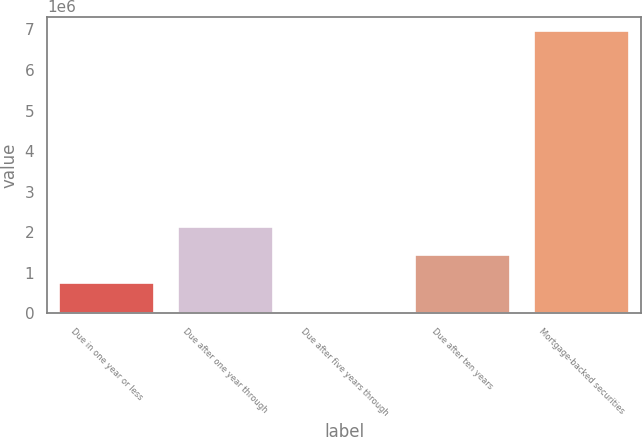Convert chart to OTSL. <chart><loc_0><loc_0><loc_500><loc_500><bar_chart><fcel>Due in one year or less<fcel>Due after one year through<fcel>Due after five years through<fcel>Due after ten years<fcel>Mortgage-backed securities<nl><fcel>737715<fcel>2.12226e+06<fcel>45441<fcel>1.42999e+06<fcel>6.96818e+06<nl></chart> 